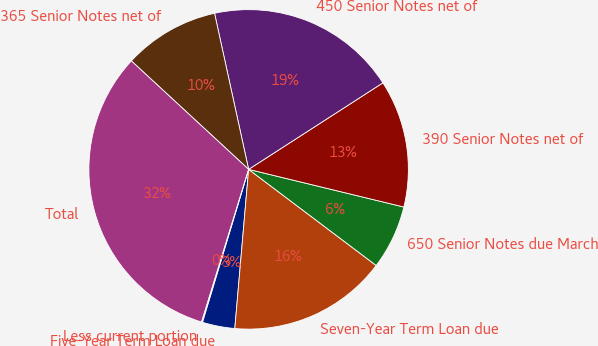Convert chart to OTSL. <chart><loc_0><loc_0><loc_500><loc_500><pie_chart><fcel>Five-Year Term Loan due<fcel>Seven-Year Term Loan due<fcel>650 Senior Notes due March<fcel>390 Senior Notes net of<fcel>450 Senior Notes net of<fcel>365 Senior Notes net of<fcel>Total<fcel>Less current portion<nl><fcel>3.29%<fcel>16.1%<fcel>6.49%<fcel>12.9%<fcel>19.31%<fcel>9.7%<fcel>32.12%<fcel>0.09%<nl></chart> 